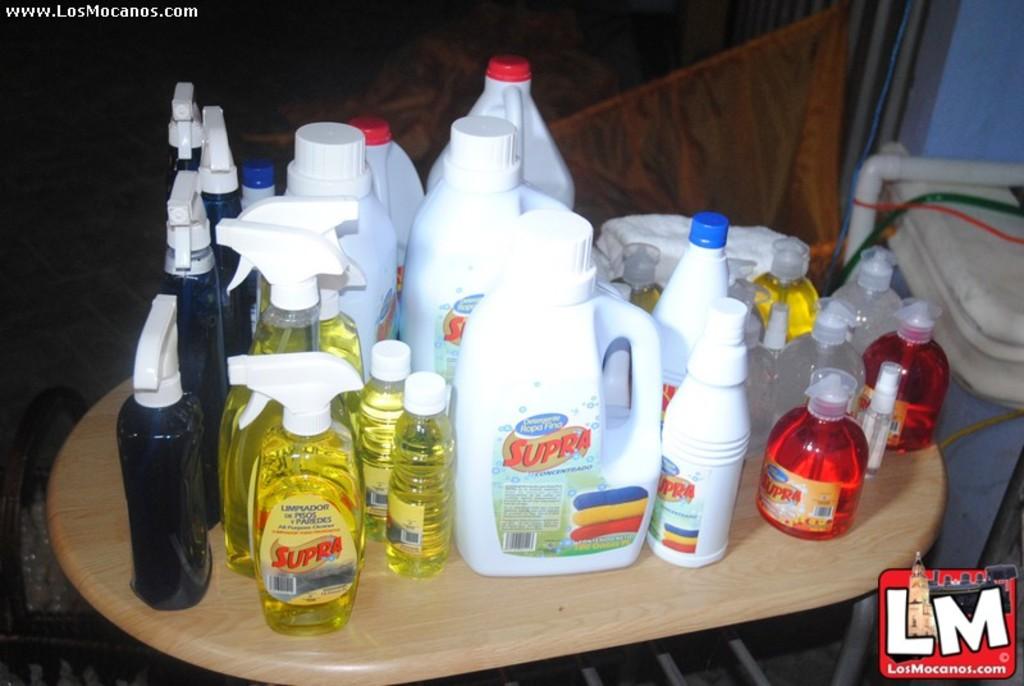Which two letters are on the lower right of the picture?
Offer a very short reply. Lm. 